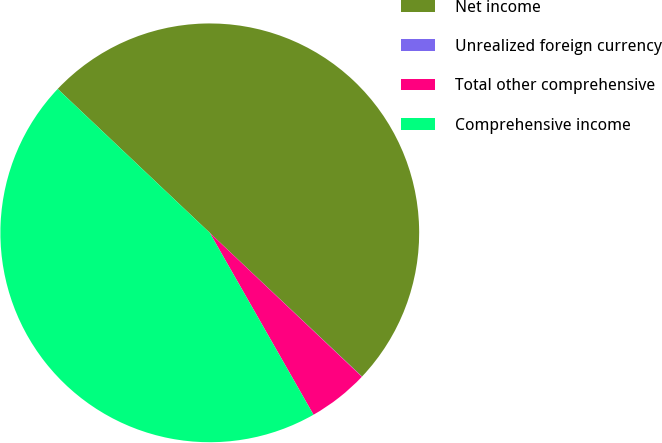Convert chart to OTSL. <chart><loc_0><loc_0><loc_500><loc_500><pie_chart><fcel>Net income<fcel>Unrealized foreign currency<fcel>Total other comprehensive<fcel>Comprehensive income<nl><fcel>49.98%<fcel>0.02%<fcel>4.69%<fcel>45.31%<nl></chart> 